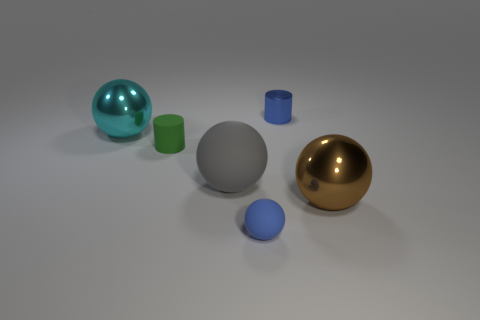Add 2 tiny metallic cylinders. How many objects exist? 8 Subtract all blue balls. How many balls are left? 3 Subtract 2 cylinders. How many cylinders are left? 0 Subtract all cyan balls. How many balls are left? 3 Subtract all cylinders. How many objects are left? 4 Subtract 1 green cylinders. How many objects are left? 5 Subtract all red cylinders. Subtract all blue spheres. How many cylinders are left? 2 Subtract all cyan cubes. Subtract all small metallic cylinders. How many objects are left? 5 Add 3 cyan objects. How many cyan objects are left? 4 Add 4 red matte blocks. How many red matte blocks exist? 4 